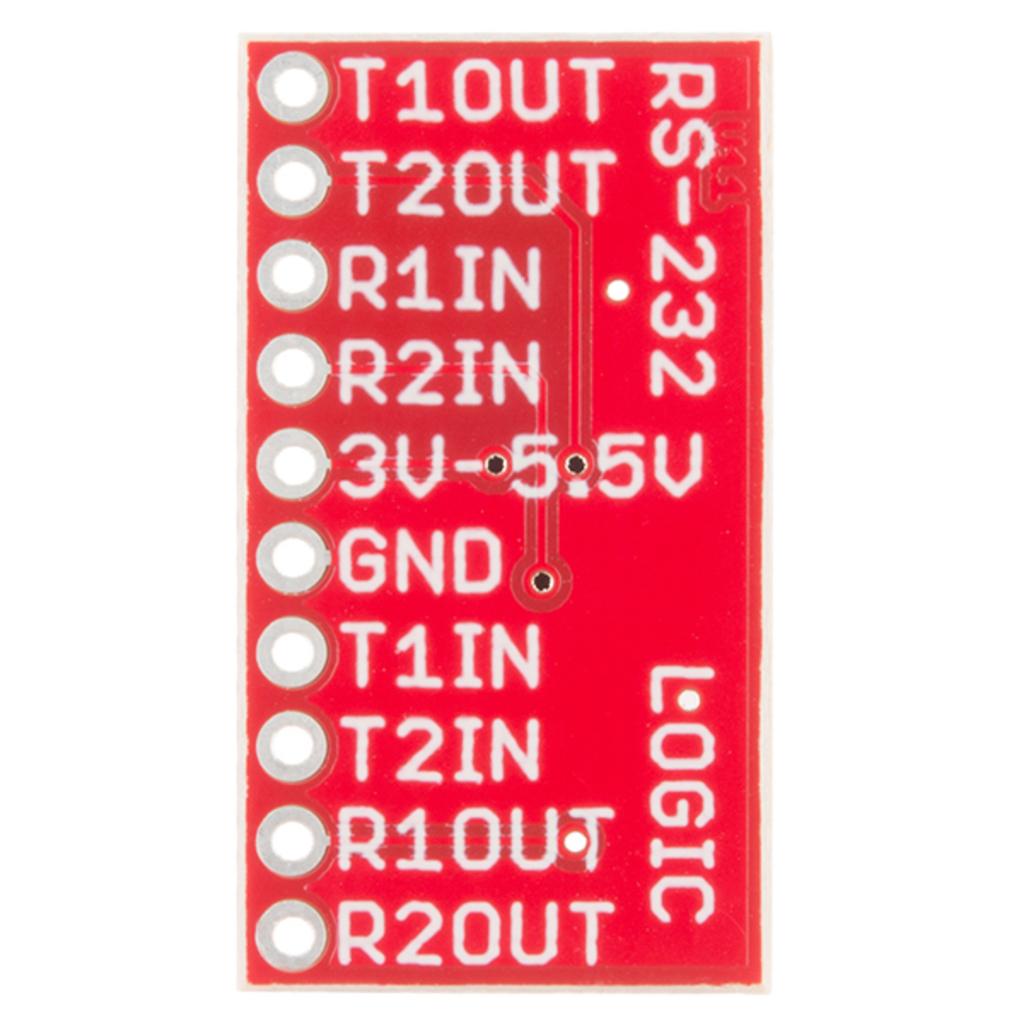What is the only word on this?
Ensure brevity in your answer.  Logic. What is written on the last line?
Provide a short and direct response. R2out. 